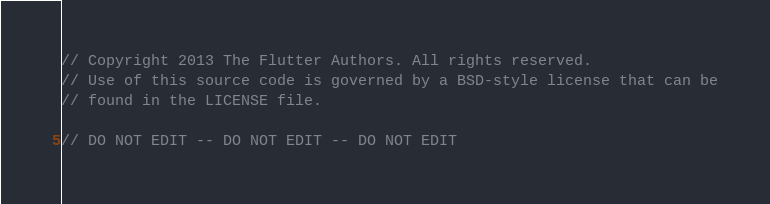Convert code to text. <code><loc_0><loc_0><loc_500><loc_500><_Dart_>// Copyright 2013 The Flutter Authors. All rights reserved.
// Use of this source code is governed by a BSD-style license that can be
// found in the LICENSE file.

// DO NOT EDIT -- DO NOT EDIT -- DO NOT EDIT</code> 